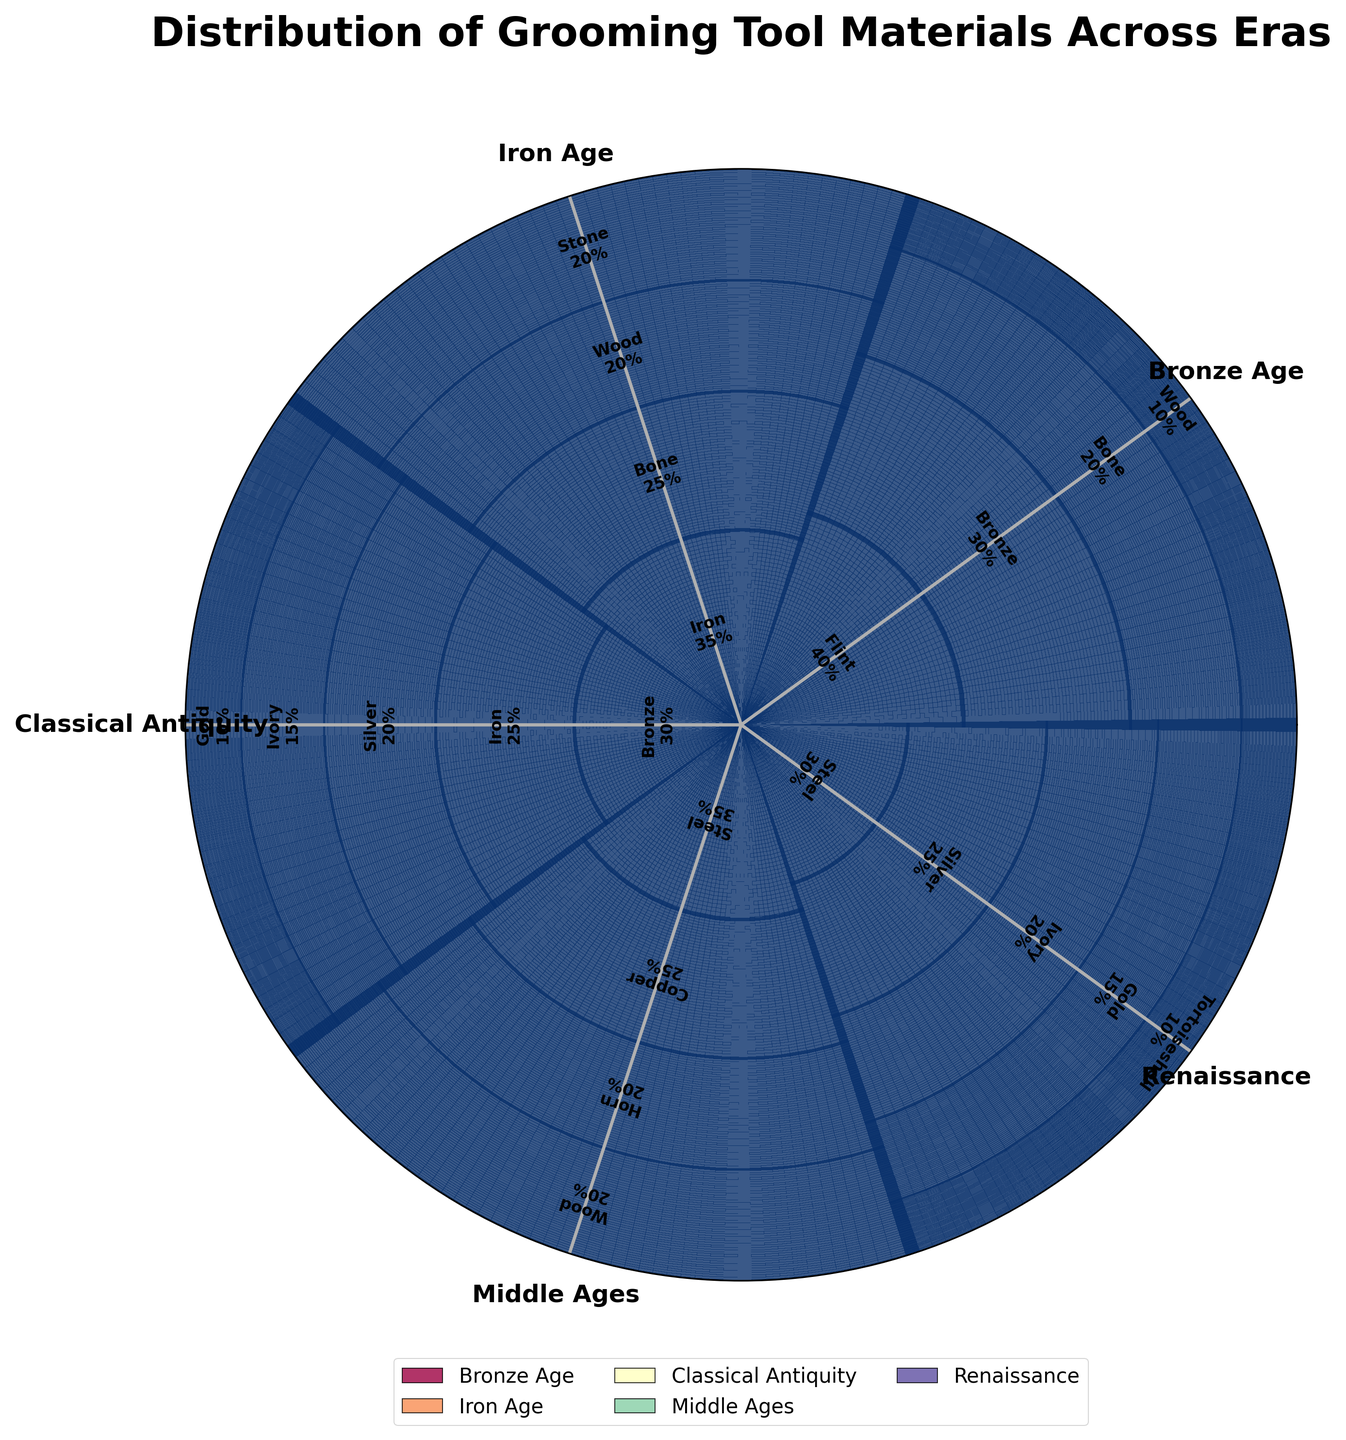What is the most common material used in grooming tools during the Bronze Age? The materials used in the Bronze Age are Flint (40%), Bronze (30%), Bone (20%), and Wood (10%). The highest percentage is for Flint.
Answer: Flint Which era has the highest variety of materials used in grooming tools? Examine the number of distinct materials for each era: Bronze Age (4), Iron Age (4), Classical Antiquity (5), Middle Ages (4), Renaissance (5). Classical Antiquity and Renaissance both have 5 materials each, more than any other era.
Answer: Classical Antiquity, Renaissance In which era was Steel a common grooming tool material? Check the eras where Steel is listed: Middle Ages (35%) and Renaissance (30%). Therefore, Steel was common in both the Middle Ages and the Renaissance.
Answer: Middle Ages, Renaissance How does the percentage of Bone used in the Iron Age compare to that in the Bronze Age? In the Iron Age, Bone accounts for 25% of materials, whereas in the Bronze Age Bone makes up 20%. Comparing these values, Bone was used in a greater percentage in the Iron Age.
Answer: Iron Age has more Bone What era has the highest percentage of Bronze? Bronze percentages by era are: Bronze Age (30%), Classical Antiquity (30%). Both eras have the highest equal percentage of Bronze at 30%.
Answer: Bronze Age, Classical Antiquity How many materials were used in grooming tools during the Iron Age? The Iron Age has the materials Iron (35%), Bone (25%), Wood (20%), and Stone (20%), summing to a total of 4 distinct materials.
Answer: 4 Which material appears in both Classical Antiquity and the Renaissance and has the same percentage? Both Classical Antiquity and Renaissance list Silver, with Classical Antiquity at 20% and Renaissance at 25%. The only common material is Silver.
Answer: Silver What is the total percentage of materials made from organic sources (e.g., Bone, Wood) in the Bronze Age? In the Bronze Age, Bone accounts for 20% and Wood for 10%, summing to a total of 30%.
Answer: 30% Which eras use Gold in grooming tools, and what is the combined percentage? Gold is used in Classical Antiquity (10%) and the Renaissance (15%). Adding these values gives a combined percentage of 25%.
Answer: 25% Which material increased in usage from the Bronze Age to the Iron Age? Compare the materials used in both the Bronze and Iron Ages: Bone increases from 20% in the Bronze Age to 25% in the Iron Age.
Answer: Bone 